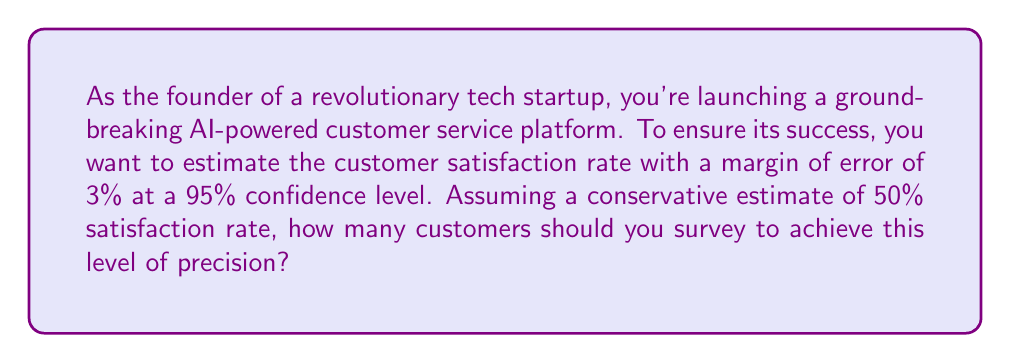Show me your answer to this math problem. Let's approach this step-by-step:

1) The formula for determining sample size for a proportion is:

   $$n = \frac{z^2 \cdot p(1-p)}{E^2}$$

   Where:
   $n$ = sample size
   $z$ = z-score for the desired confidence level
   $p$ = estimated proportion
   $E$ = margin of error

2) We're given:
   - Confidence level = 95% (z-score = 1.96)
   - Margin of error (E) = 3% = 0.03
   - Estimated proportion (p) = 50% = 0.5 (conservative estimate)

3) Let's substitute these values into our formula:

   $$n = \frac{1.96^2 \cdot 0.5(1-0.5)}{0.03^2}$$

4) Simplify:
   $$n = \frac{1.96^2 \cdot 0.25}{0.0009}$$

5) Calculate:
   $$n = \frac{0.9604}{0.0009} = 1067.11$$

6) Since we can't survey a fraction of a person, we round up to the nearest whole number.

Therefore, you should survey at least 1068 customers to estimate the satisfaction rate with a 3% margin of error at a 95% confidence level.
Answer: 1068 customers 